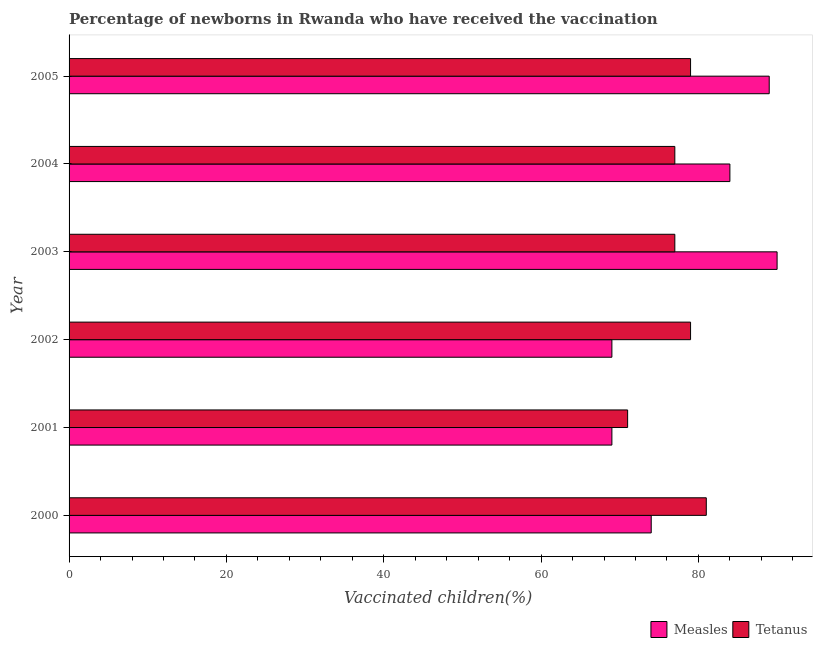How many groups of bars are there?
Your response must be concise. 6. Are the number of bars on each tick of the Y-axis equal?
Your answer should be compact. Yes. How many bars are there on the 4th tick from the top?
Keep it short and to the point. 2. How many bars are there on the 4th tick from the bottom?
Make the answer very short. 2. What is the label of the 1st group of bars from the top?
Keep it short and to the point. 2005. What is the percentage of newborns who received vaccination for measles in 2004?
Your answer should be very brief. 84. Across all years, what is the maximum percentage of newborns who received vaccination for tetanus?
Keep it short and to the point. 81. Across all years, what is the minimum percentage of newborns who received vaccination for measles?
Your answer should be compact. 69. What is the total percentage of newborns who received vaccination for measles in the graph?
Ensure brevity in your answer.  475. What is the difference between the percentage of newborns who received vaccination for measles in 2001 and the percentage of newborns who received vaccination for tetanus in 2005?
Your answer should be compact. -10. What is the average percentage of newborns who received vaccination for measles per year?
Ensure brevity in your answer.  79.17. In the year 2002, what is the difference between the percentage of newborns who received vaccination for tetanus and percentage of newborns who received vaccination for measles?
Your answer should be compact. 10. In how many years, is the percentage of newborns who received vaccination for tetanus greater than 84 %?
Make the answer very short. 0. What is the ratio of the percentage of newborns who received vaccination for tetanus in 2002 to that in 2004?
Your response must be concise. 1.03. Is the percentage of newborns who received vaccination for tetanus in 2002 less than that in 2004?
Your answer should be very brief. No. Is the difference between the percentage of newborns who received vaccination for tetanus in 2002 and 2003 greater than the difference between the percentage of newborns who received vaccination for measles in 2002 and 2003?
Make the answer very short. Yes. What is the difference between the highest and the second highest percentage of newborns who received vaccination for tetanus?
Offer a very short reply. 2. What is the difference between the highest and the lowest percentage of newborns who received vaccination for tetanus?
Your answer should be compact. 10. In how many years, is the percentage of newborns who received vaccination for tetanus greater than the average percentage of newborns who received vaccination for tetanus taken over all years?
Make the answer very short. 3. Is the sum of the percentage of newborns who received vaccination for tetanus in 2003 and 2004 greater than the maximum percentage of newborns who received vaccination for measles across all years?
Ensure brevity in your answer.  Yes. What does the 1st bar from the top in 2004 represents?
Give a very brief answer. Tetanus. What does the 1st bar from the bottom in 2005 represents?
Offer a terse response. Measles. How many years are there in the graph?
Your answer should be compact. 6. Does the graph contain grids?
Provide a succinct answer. No. Where does the legend appear in the graph?
Your response must be concise. Bottom right. How are the legend labels stacked?
Give a very brief answer. Horizontal. What is the title of the graph?
Provide a short and direct response. Percentage of newborns in Rwanda who have received the vaccination. Does "Quasi money growth" appear as one of the legend labels in the graph?
Your answer should be very brief. No. What is the label or title of the X-axis?
Provide a short and direct response. Vaccinated children(%)
. What is the label or title of the Y-axis?
Your answer should be very brief. Year. What is the Vaccinated children(%)
 of Tetanus in 2001?
Offer a terse response. 71. What is the Vaccinated children(%)
 of Measles in 2002?
Ensure brevity in your answer.  69. What is the Vaccinated children(%)
 of Tetanus in 2002?
Your answer should be compact. 79. What is the Vaccinated children(%)
 in Measles in 2004?
Your answer should be very brief. 84. What is the Vaccinated children(%)
 in Tetanus in 2004?
Keep it short and to the point. 77. What is the Vaccinated children(%)
 of Measles in 2005?
Ensure brevity in your answer.  89. What is the Vaccinated children(%)
 in Tetanus in 2005?
Keep it short and to the point. 79. Across all years, what is the minimum Vaccinated children(%)
 of Measles?
Your answer should be compact. 69. What is the total Vaccinated children(%)
 of Measles in the graph?
Provide a succinct answer. 475. What is the total Vaccinated children(%)
 of Tetanus in the graph?
Offer a very short reply. 464. What is the difference between the Vaccinated children(%)
 of Tetanus in 2000 and that in 2002?
Give a very brief answer. 2. What is the difference between the Vaccinated children(%)
 of Tetanus in 2000 and that in 2003?
Keep it short and to the point. 4. What is the difference between the Vaccinated children(%)
 in Tetanus in 2000 and that in 2004?
Your answer should be very brief. 4. What is the difference between the Vaccinated children(%)
 in Measles in 2000 and that in 2005?
Provide a succinct answer. -15. What is the difference between the Vaccinated children(%)
 of Measles in 2001 and that in 2002?
Give a very brief answer. 0. What is the difference between the Vaccinated children(%)
 of Tetanus in 2001 and that in 2002?
Your answer should be very brief. -8. What is the difference between the Vaccinated children(%)
 in Measles in 2001 and that in 2003?
Make the answer very short. -21. What is the difference between the Vaccinated children(%)
 of Tetanus in 2001 and that in 2003?
Make the answer very short. -6. What is the difference between the Vaccinated children(%)
 in Tetanus in 2001 and that in 2004?
Ensure brevity in your answer.  -6. What is the difference between the Vaccinated children(%)
 in Measles in 2001 and that in 2005?
Make the answer very short. -20. What is the difference between the Vaccinated children(%)
 in Tetanus in 2002 and that in 2004?
Your response must be concise. 2. What is the difference between the Vaccinated children(%)
 in Measles in 2003 and that in 2004?
Your answer should be very brief. 6. What is the difference between the Vaccinated children(%)
 of Measles in 2003 and that in 2005?
Provide a succinct answer. 1. What is the difference between the Vaccinated children(%)
 of Measles in 2004 and that in 2005?
Provide a short and direct response. -5. What is the difference between the Vaccinated children(%)
 of Measles in 2000 and the Vaccinated children(%)
 of Tetanus in 2001?
Offer a terse response. 3. What is the difference between the Vaccinated children(%)
 in Measles in 2000 and the Vaccinated children(%)
 in Tetanus in 2002?
Give a very brief answer. -5. What is the difference between the Vaccinated children(%)
 in Measles in 2000 and the Vaccinated children(%)
 in Tetanus in 2004?
Ensure brevity in your answer.  -3. What is the difference between the Vaccinated children(%)
 of Measles in 2000 and the Vaccinated children(%)
 of Tetanus in 2005?
Keep it short and to the point. -5. What is the difference between the Vaccinated children(%)
 of Measles in 2001 and the Vaccinated children(%)
 of Tetanus in 2002?
Make the answer very short. -10. What is the difference between the Vaccinated children(%)
 of Measles in 2001 and the Vaccinated children(%)
 of Tetanus in 2003?
Offer a very short reply. -8. What is the difference between the Vaccinated children(%)
 in Measles in 2001 and the Vaccinated children(%)
 in Tetanus in 2004?
Give a very brief answer. -8. What is the difference between the Vaccinated children(%)
 of Measles in 2001 and the Vaccinated children(%)
 of Tetanus in 2005?
Provide a short and direct response. -10. What is the difference between the Vaccinated children(%)
 of Measles in 2002 and the Vaccinated children(%)
 of Tetanus in 2003?
Keep it short and to the point. -8. What is the difference between the Vaccinated children(%)
 of Measles in 2002 and the Vaccinated children(%)
 of Tetanus in 2004?
Your response must be concise. -8. What is the difference between the Vaccinated children(%)
 in Measles in 2002 and the Vaccinated children(%)
 in Tetanus in 2005?
Provide a succinct answer. -10. What is the average Vaccinated children(%)
 in Measles per year?
Make the answer very short. 79.17. What is the average Vaccinated children(%)
 in Tetanus per year?
Your answer should be very brief. 77.33. In the year 2000, what is the difference between the Vaccinated children(%)
 in Measles and Vaccinated children(%)
 in Tetanus?
Your answer should be compact. -7. In the year 2001, what is the difference between the Vaccinated children(%)
 in Measles and Vaccinated children(%)
 in Tetanus?
Offer a terse response. -2. In the year 2004, what is the difference between the Vaccinated children(%)
 of Measles and Vaccinated children(%)
 of Tetanus?
Provide a succinct answer. 7. In the year 2005, what is the difference between the Vaccinated children(%)
 of Measles and Vaccinated children(%)
 of Tetanus?
Your answer should be compact. 10. What is the ratio of the Vaccinated children(%)
 in Measles in 2000 to that in 2001?
Make the answer very short. 1.07. What is the ratio of the Vaccinated children(%)
 of Tetanus in 2000 to that in 2001?
Ensure brevity in your answer.  1.14. What is the ratio of the Vaccinated children(%)
 of Measles in 2000 to that in 2002?
Provide a short and direct response. 1.07. What is the ratio of the Vaccinated children(%)
 in Tetanus in 2000 to that in 2002?
Provide a succinct answer. 1.03. What is the ratio of the Vaccinated children(%)
 of Measles in 2000 to that in 2003?
Your response must be concise. 0.82. What is the ratio of the Vaccinated children(%)
 in Tetanus in 2000 to that in 2003?
Your answer should be compact. 1.05. What is the ratio of the Vaccinated children(%)
 in Measles in 2000 to that in 2004?
Your response must be concise. 0.88. What is the ratio of the Vaccinated children(%)
 of Tetanus in 2000 to that in 2004?
Give a very brief answer. 1.05. What is the ratio of the Vaccinated children(%)
 of Measles in 2000 to that in 2005?
Provide a succinct answer. 0.83. What is the ratio of the Vaccinated children(%)
 of Tetanus in 2000 to that in 2005?
Provide a succinct answer. 1.03. What is the ratio of the Vaccinated children(%)
 of Tetanus in 2001 to that in 2002?
Give a very brief answer. 0.9. What is the ratio of the Vaccinated children(%)
 of Measles in 2001 to that in 2003?
Make the answer very short. 0.77. What is the ratio of the Vaccinated children(%)
 in Tetanus in 2001 to that in 2003?
Your response must be concise. 0.92. What is the ratio of the Vaccinated children(%)
 of Measles in 2001 to that in 2004?
Give a very brief answer. 0.82. What is the ratio of the Vaccinated children(%)
 in Tetanus in 2001 to that in 2004?
Provide a short and direct response. 0.92. What is the ratio of the Vaccinated children(%)
 of Measles in 2001 to that in 2005?
Ensure brevity in your answer.  0.78. What is the ratio of the Vaccinated children(%)
 in Tetanus in 2001 to that in 2005?
Provide a short and direct response. 0.9. What is the ratio of the Vaccinated children(%)
 of Measles in 2002 to that in 2003?
Ensure brevity in your answer.  0.77. What is the ratio of the Vaccinated children(%)
 in Tetanus in 2002 to that in 2003?
Provide a succinct answer. 1.03. What is the ratio of the Vaccinated children(%)
 in Measles in 2002 to that in 2004?
Provide a succinct answer. 0.82. What is the ratio of the Vaccinated children(%)
 of Measles in 2002 to that in 2005?
Keep it short and to the point. 0.78. What is the ratio of the Vaccinated children(%)
 in Measles in 2003 to that in 2004?
Offer a very short reply. 1.07. What is the ratio of the Vaccinated children(%)
 of Measles in 2003 to that in 2005?
Your response must be concise. 1.01. What is the ratio of the Vaccinated children(%)
 of Tetanus in 2003 to that in 2005?
Provide a short and direct response. 0.97. What is the ratio of the Vaccinated children(%)
 of Measles in 2004 to that in 2005?
Provide a succinct answer. 0.94. What is the ratio of the Vaccinated children(%)
 of Tetanus in 2004 to that in 2005?
Keep it short and to the point. 0.97. What is the difference between the highest and the second highest Vaccinated children(%)
 in Measles?
Keep it short and to the point. 1. What is the difference between the highest and the lowest Vaccinated children(%)
 in Measles?
Your response must be concise. 21. What is the difference between the highest and the lowest Vaccinated children(%)
 in Tetanus?
Make the answer very short. 10. 